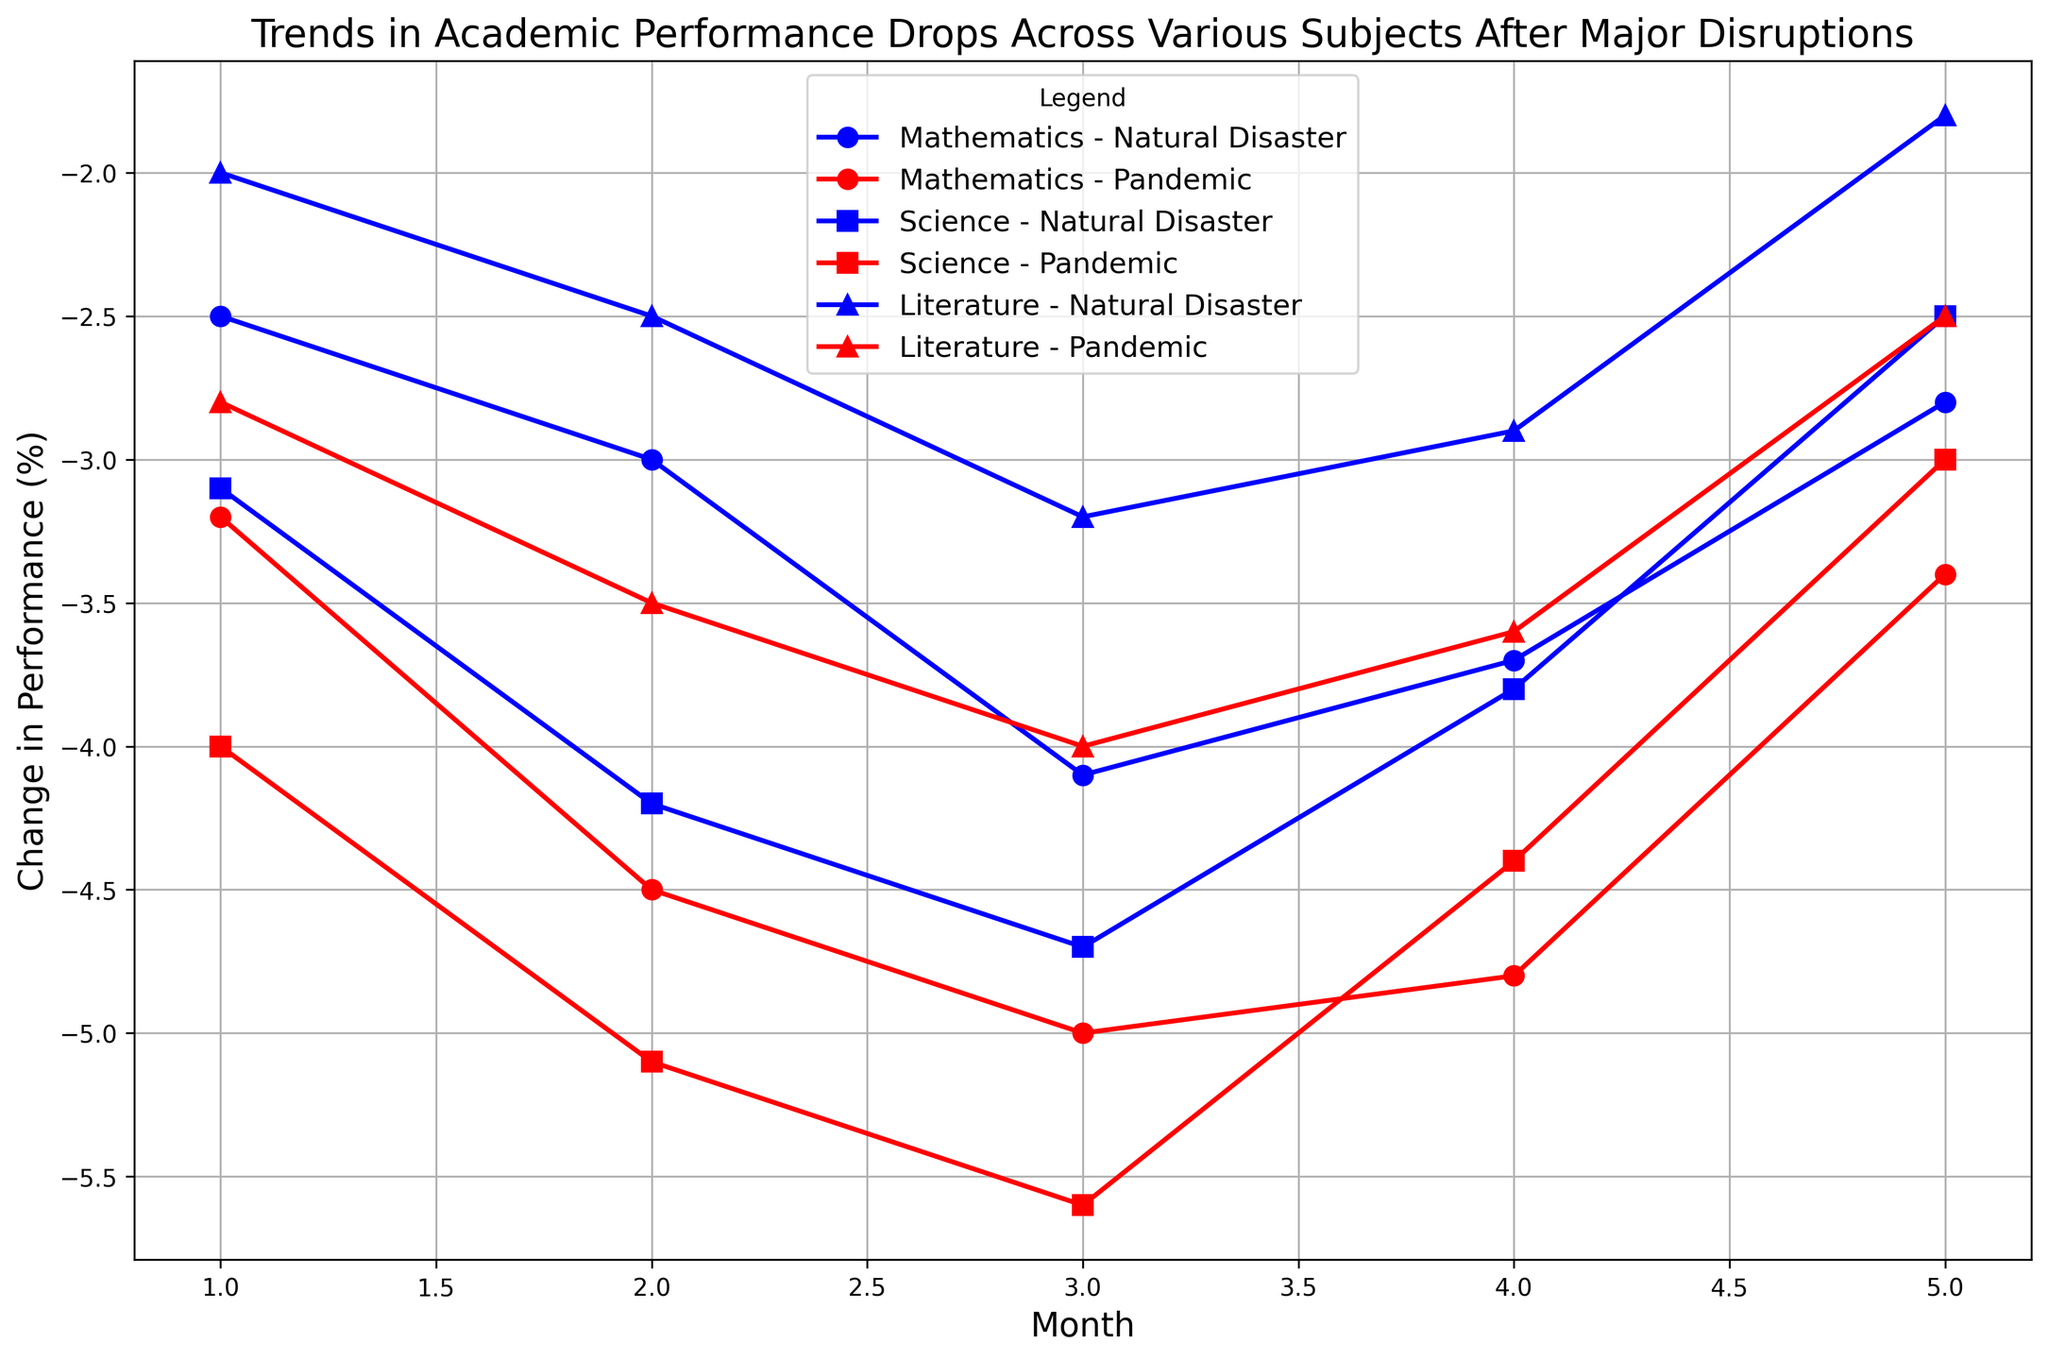What is the overall trend in the academic performance of Science after a Pandemic? The performance drop in Science starts at -4.0 in the first month, increases to -5.1 in the second month, peaks at -5.6 in the third month, then gradually decreases to -4.4 in the fourth month, and further decreases to -3.0 in the fifth month.
Answer: Decreasing initially, then increasing steadily Which subject shows the least performance drop in the first month after a Natural Disaster? The first-month performance drops after a Natural Disaster are -2.5 for Mathematics, -3.1 for Science, and -2.0 for Literature. Literature has the least drop.
Answer: Literature How does the drop in Mathematics performance compare between the third and fifth months after a Pandemic? The performance drop in Mathematics after a Pandemic is -5.0 in the third month and -3.4 in the fifth month. The difference is -5.0 - (-3.4) = -1.6.
Answer: -1.6 Which disruption caused a sharper initial drop in Science performance, Natural Disaster or Pandemic? The initial drops in Science are -3.1 for Natural Disaster and -4.0 for Pandemic. The drop caused by the Pandemic (-4.0) is sharper.
Answer: Pandemic On average, how does the Mathematics performance change over the five months following a Natural Disaster? The performance drops in Mathematics over five months after a Natural Disaster are -2.5, -3.0, -4.1, -3.7, and -2.8. The average is (-2.5 + -3.0 + -4.1 + -3.7 + -2.8) / 5 = -3.22.
Answer: -3.22 What is the most noticeable trend in Literature performance following a Natural Disaster? After a Natural Disaster, Literature shows performance drops of -2.0, -2.5, -3.2, -2.9, and -1.8 over five months. The trend is that after an initial larger drop, the performance begins to recover, with the drop reducing by the fifth month.
Answer: Recovering after an initial drop Which subject experienced the largest drop in the second month after a Pandemic? In the second month after a Pandemic, Mathematics dropped by -4.5, Science by -5.1, and Literature by -3.5. Science experienced the largest drop.
Answer: Science By how much did the performance in Science improve from the fourth to the fifth month after a Natural Disaster? The performance drop in Science after a Natural Disaster is -3.8 in the fourth month and -2.5 in the fifth month. The improvement is -3.8 - (-2.5) = -1.3.
Answer: 1.3 Is there a month where the drop in academic performance for all subjects and both disruptions is the greatest? In the third month, the performance drops for Mathematics are -4.1 (Natural Disaster) and -5.0 (Pandemic), for Science are -4.7 (Natural Disaster) and -5.6 (Pandemic), and for Literature are -3.2 (Natural Disaster) and -4.0 (Pandemic). The overall maximum drops for both disruptions across subjects occur in this month.
Answer: Third month 